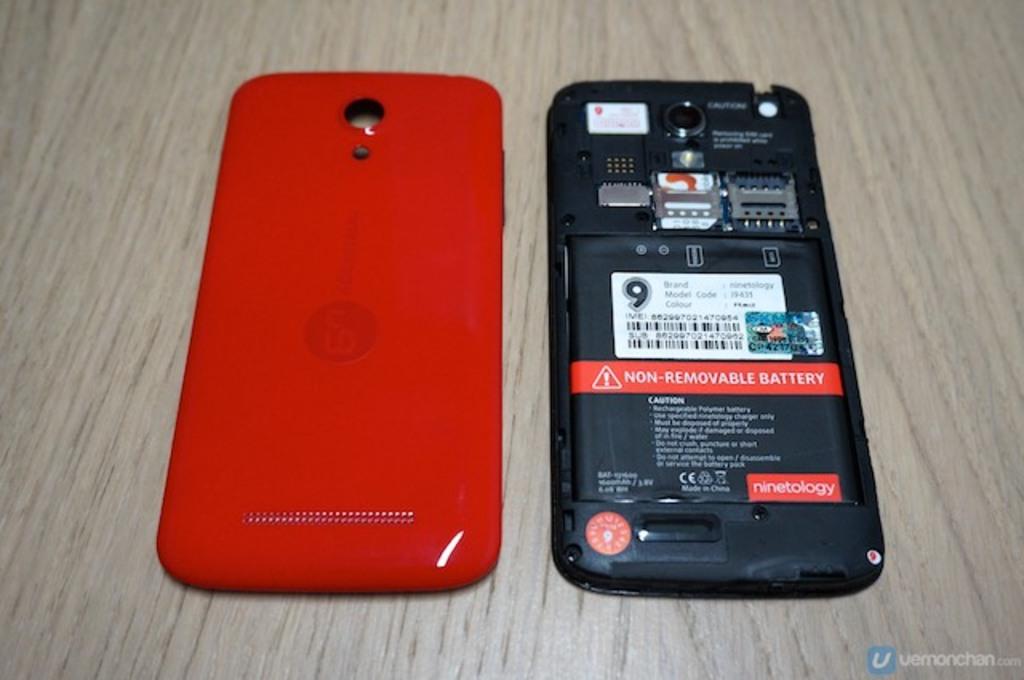Is the battery removable or non-removable?
Offer a terse response. Non-removable. Is this battery made by ninetology?
Provide a short and direct response. Yes. 